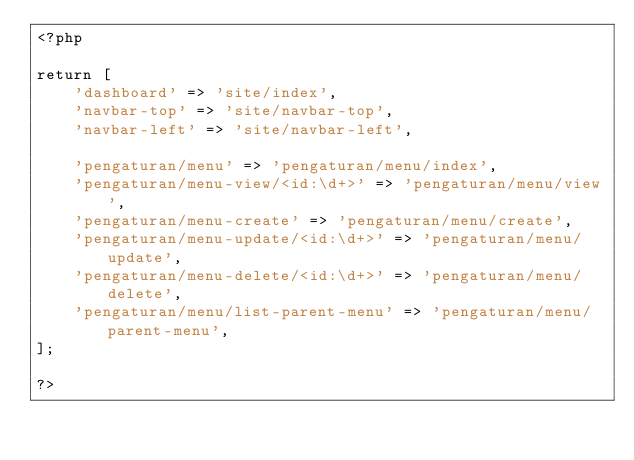<code> <loc_0><loc_0><loc_500><loc_500><_PHP_><?php 

return [
    'dashboard' => 'site/index',
    'navbar-top' => 'site/navbar-top',
    'navbar-left' => 'site/navbar-left',

    'pengaturan/menu' => 'pengaturan/menu/index',
    'pengaturan/menu-view/<id:\d+>' => 'pengaturan/menu/view',
    'pengaturan/menu-create' => 'pengaturan/menu/create',
    'pengaturan/menu-update/<id:\d+>' => 'pengaturan/menu/update',
    'pengaturan/menu-delete/<id:\d+>' => 'pengaturan/menu/delete',
    'pengaturan/menu/list-parent-menu' => 'pengaturan/menu/parent-menu',
];

?>
</code> 